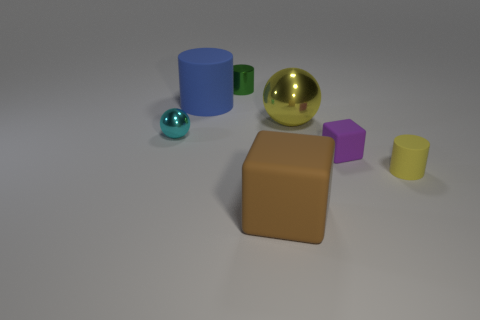Do the big ball and the cylinder that is right of the small purple block have the same color?
Make the answer very short. Yes. What is the size of the cyan thing that is the same shape as the large yellow thing?
Offer a very short reply. Small. There is a matte thing that is both to the left of the yellow metal thing and in front of the small purple object; what shape is it?
Your answer should be compact. Cube. There is a yellow matte cylinder; does it have the same size as the sphere to the left of the blue object?
Offer a very short reply. Yes. What is the color of the other small matte object that is the same shape as the brown rubber object?
Offer a very short reply. Purple. There is a matte cylinder on the left side of the big metallic ball; is its size the same as the shiny sphere that is right of the large blue rubber cylinder?
Your answer should be very brief. Yes. Does the brown matte thing have the same shape as the large blue matte object?
Give a very brief answer. No. How many things are large objects to the right of the brown matte object or cylinders?
Offer a terse response. 4. Are there any small rubber objects of the same shape as the large brown thing?
Provide a short and direct response. Yes. Are there an equal number of yellow metal balls behind the large rubber cylinder and tiny red cylinders?
Your answer should be compact. Yes. 